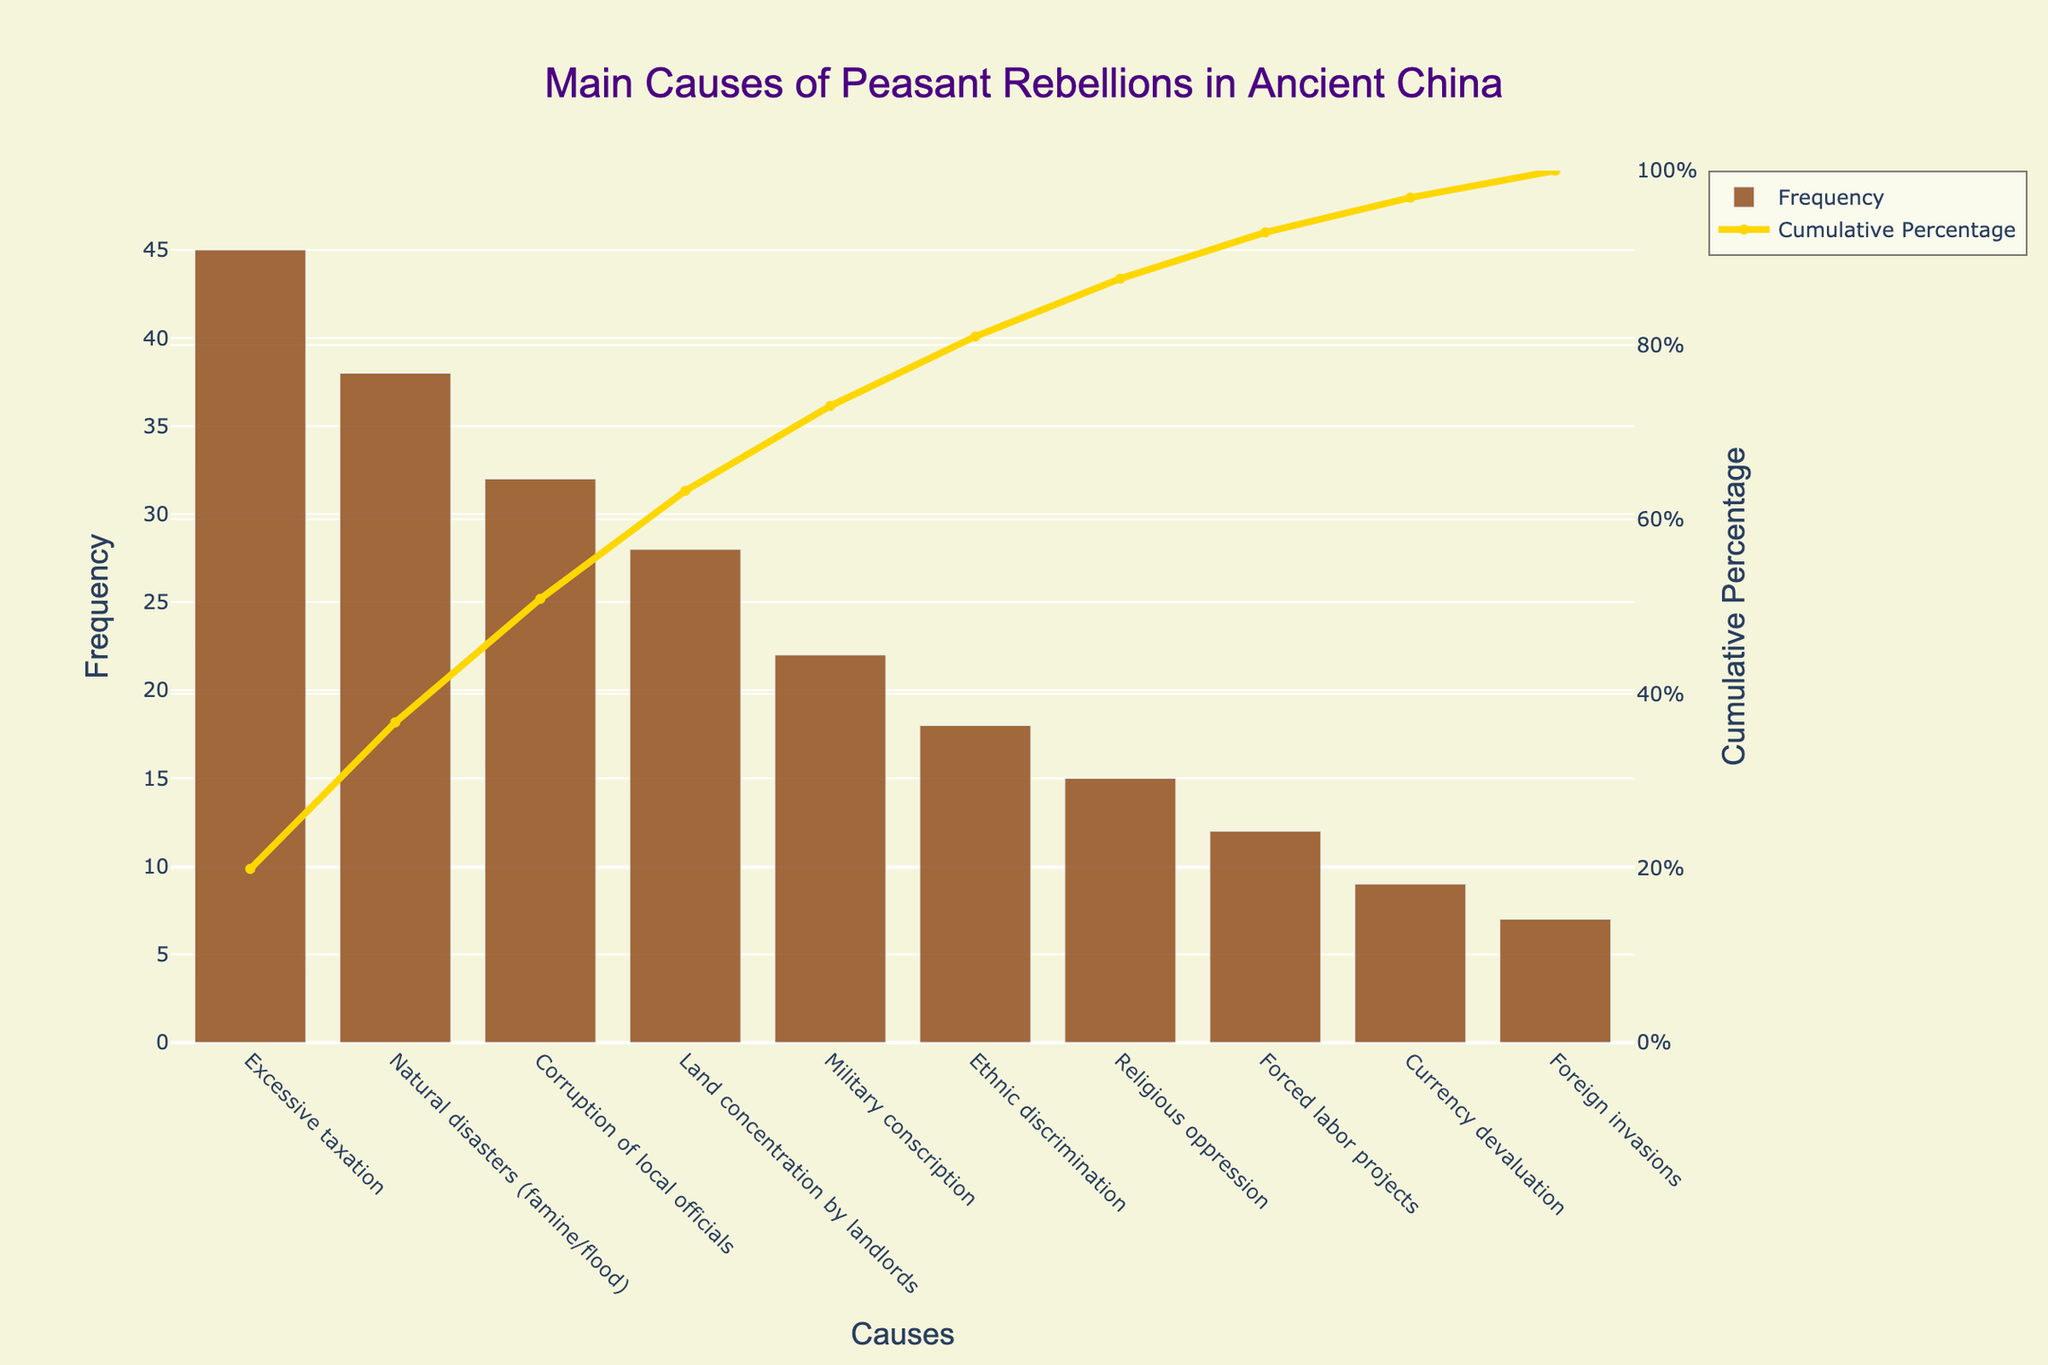What is the most frequent cause of peasant rebellions in ancient China? The most frequent cause can be identified as the tallest bar in the chart which represents the highest frequency. The tallest bar corresponds to 'Excessive taxation'.
Answer: Excessive taxation What is the cumulative percentage of the top three causes of peasant rebellions? To find this, look at the cumulative percentage line and sum the percentages corresponding to the top three causes: 'Excessive taxation', 'Natural disasters (famine/flood)', and 'Corruption of local officials'. From the figure, these are 31.91% + 59.57% + 82.61%.
Answer: 82.61% How many causes have a frequency greater than 25? Count the number of bars with heights above the value 25 on the frequency axis. The causes are 'Excessive taxation', 'Natural disasters (famine/flood)', 'Corruption of local officials', and 'Land concentration by landlords'. That's a total of 4 causes.
Answer: 4 How does the frequency of land concentration by landlords compare to military conscription? Compare the heights of the bars for these two causes. The frequency for 'Land concentration by landlords' is 28, while for 'Military conscription' it is 22.
Answer: Land concentration by landlords is higher What is the cumulative percentage of all causes except the three least frequent ones? Identify the cumulative percentage at the point before the last three causes ('Currency devaluation', 'Religious oppression', 'Foreign invasions'). The cumulative percentage at 'Forced labor projects', which is the last cause before these three, is 91.31%.
Answer: 91.31% What is the cumulative percentage at the point after the first five causes have been considered? Look at the cumulative percentage line after the fifth cause ('Military conscription'). The cumulative percentage at this point is 74.35%.
Answer: 74.35% Which cause has the smallest impact on peasant rebellions based on frequency? The shortest bar in the chart indicates the cause with the smallest frequency. This corresponds to 'Foreign invasions' with a frequency of 7.
Answer: Foreign invasions From the Pareto chart, what percentage of the causes roughly account for 80% of the peasant rebellions? To determine this, find the point where the cumulative percentage line crosses 80%. The causes up to 'Corruption of local officials' include 3 causes out of the total 10 causes. Hence, about 30% of the causes account for roughly 80% of the rebellions.
Answer: 30% What is the combined frequency of ethnic discrimination and forced labor projects? Sum the heights of the bars for 'Ethnic discrimination' (18) and 'Forced labor projects' (12). 18 + 12 = 30.
Answer: 30 What does the y-axis on the right represent in the Pareto chart? The y-axis on the right depicts the 'Cumulative Percentage', providing the cumulative impact of the causes based on their frequencies.
Answer: Cumulative Percentage 